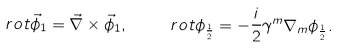Convert formula to latex. <formula><loc_0><loc_0><loc_500><loc_500>\ r o t \vec { \phi } _ { 1 } = { \vec { \nabla } } \times \vec { \phi } _ { 1 } , \quad \ r o t \phi _ { \frac { 1 } { 2 } } = - \frac { i } { 2 } \gamma ^ { m } \nabla _ { m } \phi _ { \frac { 1 } { 2 } } .</formula> 